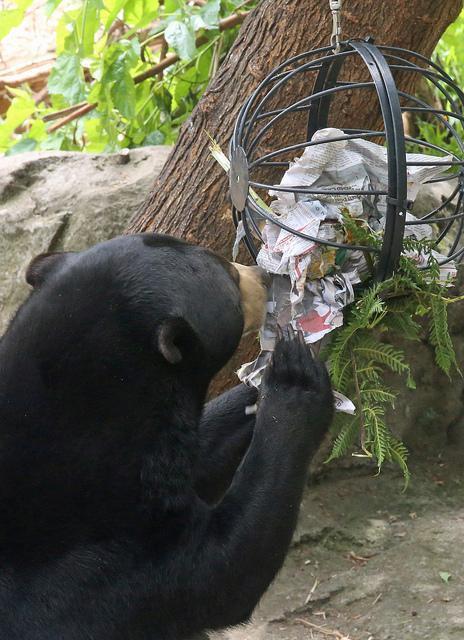How many bears are pictured?
Give a very brief answer. 1. 